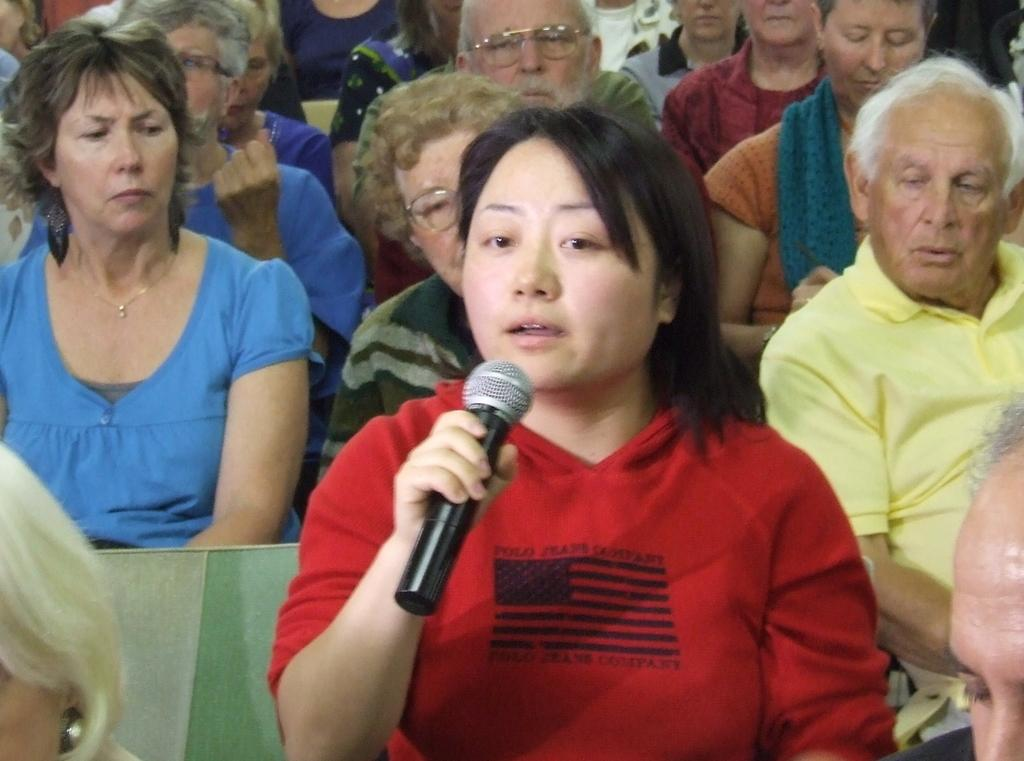Who is the main subject in the image? There is a woman in the image. What is the woman doing in the image? The woman is sitting in the image. What is the woman holding in her hand? The woman is holding a microphone in her hand. What can be seen in the background of the image? There is a group of people in the background of the image. What are the people in the background doing? The people in the background are sitting in chairs. What type of feast is being prepared in the image? There is no mention of a feast or any food preparation in the image. Can you tell me how many chickens are present in the image? There are no chickens visible in the image. 